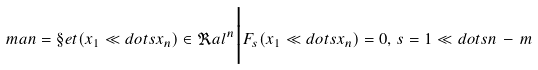Convert formula to latex. <formula><loc_0><loc_0><loc_500><loc_500>\ m a n = \S e t { ( x _ { 1 } \ll d o t s x _ { n } ) \in \Re a l ^ { n } \Big | F _ { s } ( x _ { 1 } \ll d o t s x _ { n } ) = 0 , \, s = 1 \ll d o t s n \, - \, m }</formula> 